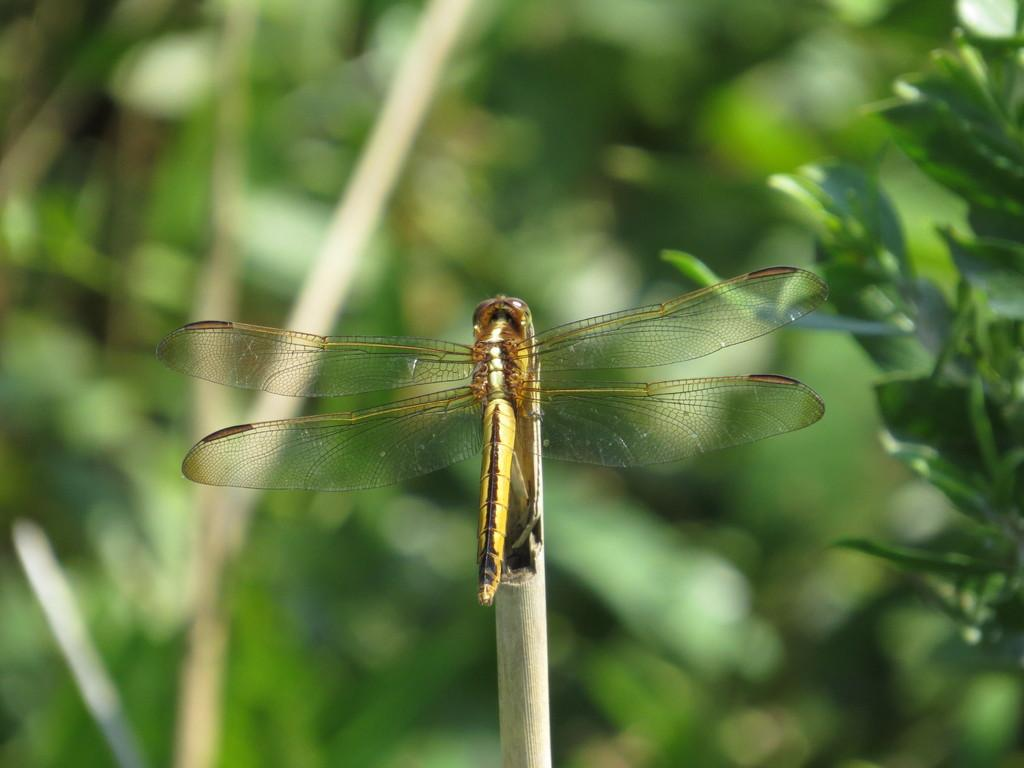What insect can be seen in the image? There is a dragonfly in the image. What is the dragonfly resting on? The dragonfly is on a wooden object. What type of vegetation is visible on the right side of the image? There are leaves on the right side of the image. How would you describe the background of the image? The background of the image is blurred. What type of book is the dragonfly holding in the image? There is no book present in the image, and the dragonfly is not holding anything. 